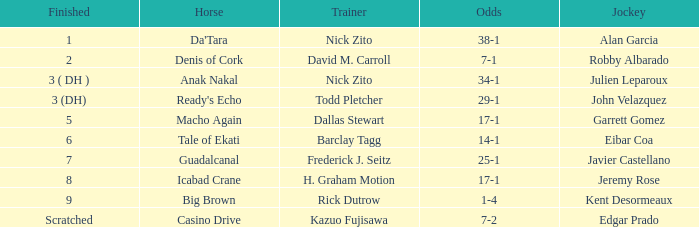Who is the Jockey that has Nick Zito as Trainer and Odds of 34-1? Julien Leparoux. 